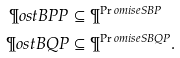<formula> <loc_0><loc_0><loc_500><loc_500>\P o s t B P P & \subseteq \P ^ { \Pr o m i s e S B P } \\ \P o s t B Q P & \subseteq \P ^ { \Pr o m i s e S B Q P } .</formula> 